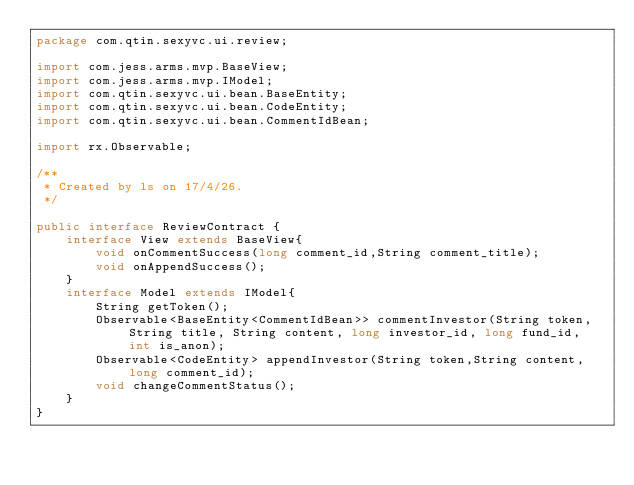<code> <loc_0><loc_0><loc_500><loc_500><_Java_>package com.qtin.sexyvc.ui.review;

import com.jess.arms.mvp.BaseView;
import com.jess.arms.mvp.IModel;
import com.qtin.sexyvc.ui.bean.BaseEntity;
import com.qtin.sexyvc.ui.bean.CodeEntity;
import com.qtin.sexyvc.ui.bean.CommentIdBean;

import rx.Observable;

/**
 * Created by ls on 17/4/26.
 */

public interface ReviewContract {
    interface View extends BaseView{
        void onCommentSuccess(long comment_id,String comment_title);
        void onAppendSuccess();
    }
    interface Model extends IModel{
        String getToken();
        Observable<BaseEntity<CommentIdBean>> commentInvestor(String token, String title, String content, long investor_id, long fund_id, int is_anon);
        Observable<CodeEntity> appendInvestor(String token,String content,long comment_id);
        void changeCommentStatus();
    }
}
</code> 